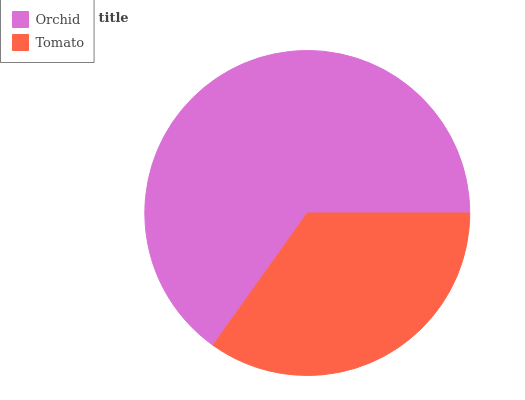Is Tomato the minimum?
Answer yes or no. Yes. Is Orchid the maximum?
Answer yes or no. Yes. Is Tomato the maximum?
Answer yes or no. No. Is Orchid greater than Tomato?
Answer yes or no. Yes. Is Tomato less than Orchid?
Answer yes or no. Yes. Is Tomato greater than Orchid?
Answer yes or no. No. Is Orchid less than Tomato?
Answer yes or no. No. Is Orchid the high median?
Answer yes or no. Yes. Is Tomato the low median?
Answer yes or no. Yes. Is Tomato the high median?
Answer yes or no. No. Is Orchid the low median?
Answer yes or no. No. 